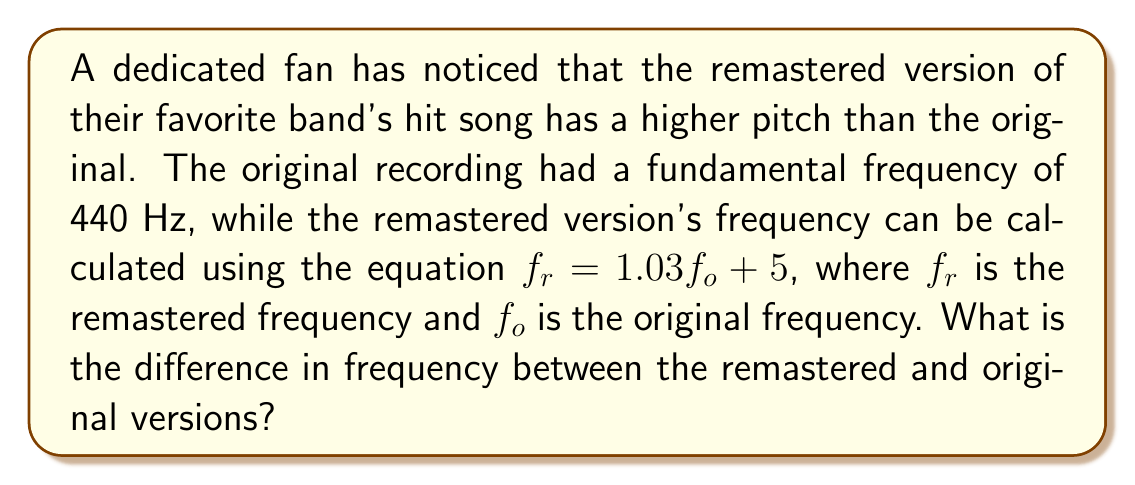What is the answer to this math problem? Let's approach this step-by-step:

1) We're given that the original frequency $f_o = 440$ Hz.

2) The equation for the remastered frequency is:
   $f_r = 1.03f_o + 5$

3) Let's substitute the known value:
   $f_r = 1.03(440) + 5$

4) First, let's multiply:
   $f_r = 453.2 + 5$

5) Now, add:
   $f_r = 458.2$ Hz

6) To find the difference, we subtract the original frequency from the remastered:
   $\text{Difference} = f_r - f_o$
   $\text{Difference} = 458.2 - 440$
   $\text{Difference} = 18.2$ Hz

Therefore, the difference in frequency between the remastered and original versions is 18.2 Hz.
Answer: 18.2 Hz 